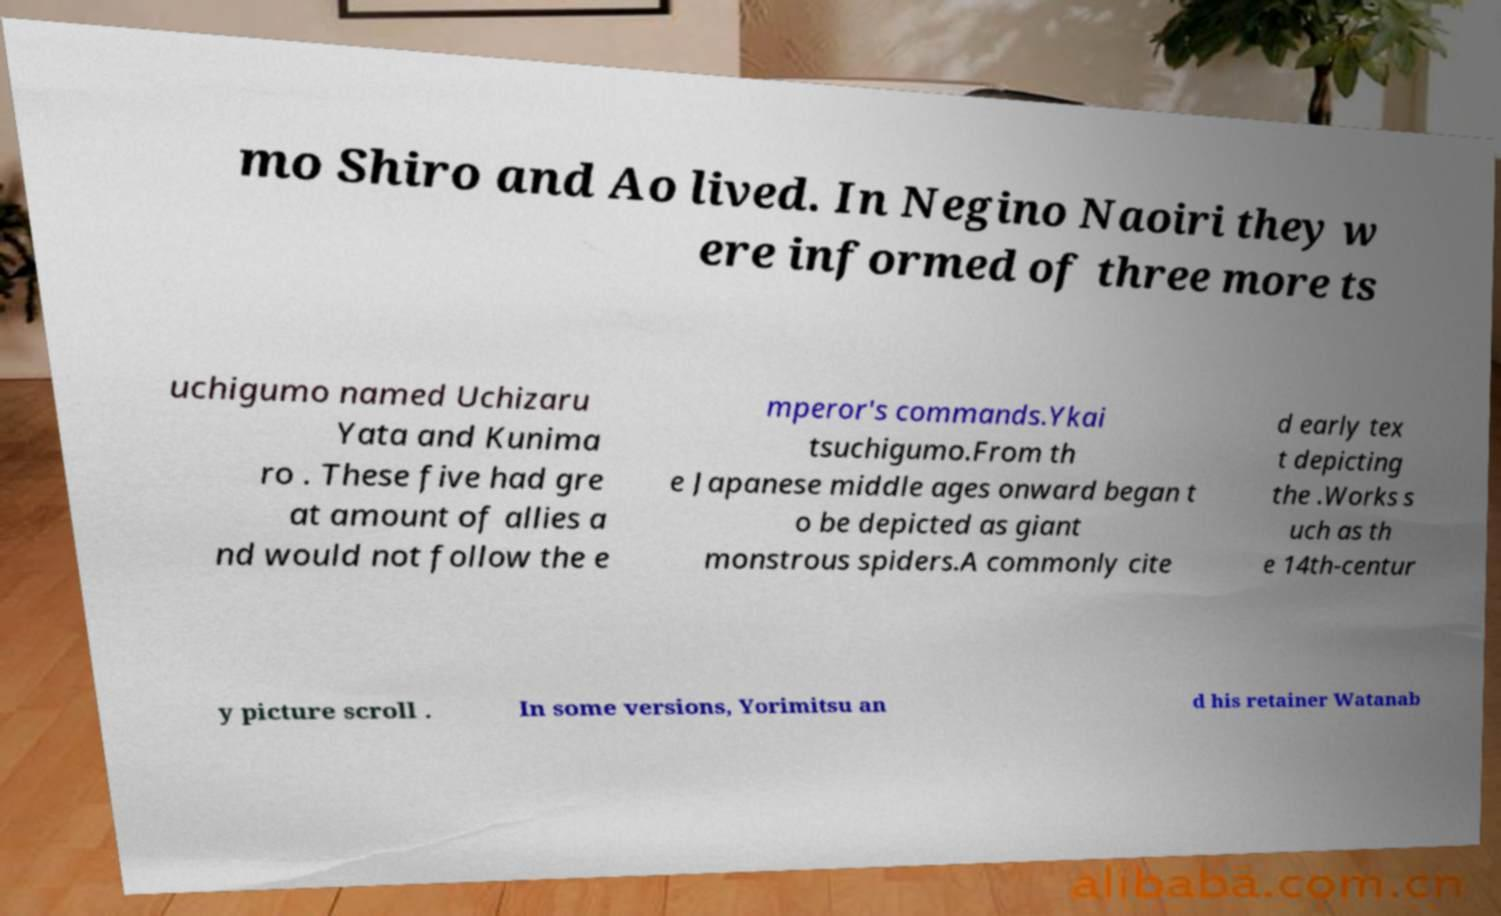Can you read and provide the text displayed in the image?This photo seems to have some interesting text. Can you extract and type it out for me? mo Shiro and Ao lived. In Negino Naoiri they w ere informed of three more ts uchigumo named Uchizaru Yata and Kunima ro . These five had gre at amount of allies a nd would not follow the e mperor's commands.Ykai tsuchigumo.From th e Japanese middle ages onward began t o be depicted as giant monstrous spiders.A commonly cite d early tex t depicting the .Works s uch as th e 14th-centur y picture scroll . In some versions, Yorimitsu an d his retainer Watanab 